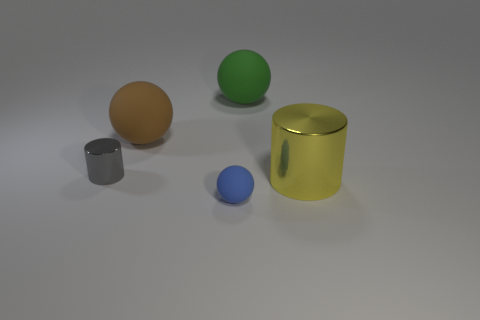There is a green matte object; how many green rubber objects are behind it?
Offer a very short reply. 0. Is the gray metallic thing the same shape as the yellow metallic thing?
Your response must be concise. Yes. How many objects are both left of the small blue thing and behind the gray object?
Keep it short and to the point. 1. How many things are either big metallic things or metallic cylinders that are to the right of the brown matte thing?
Keep it short and to the point. 1. Is the number of gray objects greater than the number of brown metal objects?
Your answer should be very brief. Yes. The metal thing in front of the tiny gray cylinder has what shape?
Provide a short and direct response. Cylinder. What number of other metallic objects are the same shape as the gray metal thing?
Your answer should be very brief. 1. What is the size of the matte object in front of the cylinder right of the tiny blue rubber ball?
Give a very brief answer. Small. How many yellow things are either spheres or large objects?
Your answer should be compact. 1. Is the number of large shiny objects behind the large yellow cylinder less than the number of spheres that are behind the brown matte ball?
Your response must be concise. Yes. 